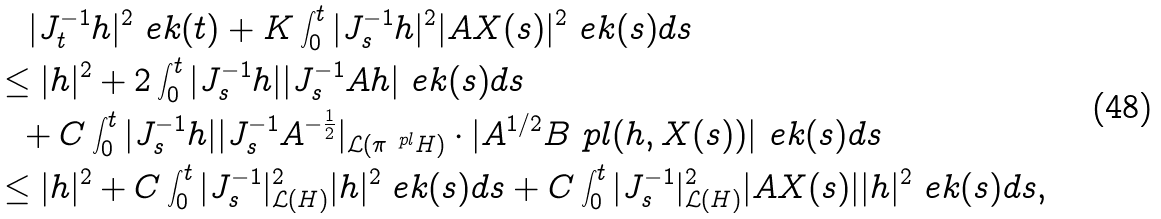Convert formula to latex. <formula><loc_0><loc_0><loc_500><loc_500>& \quad | J ^ { - 1 } _ { t } h | ^ { 2 } \ e k ( t ) + K \int _ { 0 } ^ { t } | J ^ { - 1 } _ { s } h | ^ { 2 } | A X ( s ) | ^ { 2 } \ e k ( s ) d s \\ & \leq | h | ^ { 2 } + 2 \int _ { 0 } ^ { t } | J ^ { - 1 } _ { s } h | | J ^ { - 1 } _ { s } A h | \ e k ( s ) d s \\ & \ \ + C \int _ { 0 } ^ { t } | J ^ { - 1 } _ { s } h | | J ^ { - 1 } _ { s } A ^ { - \frac { 1 } { 2 } } | _ { \mathcal { L } ( \pi ^ { \ p l } H ) } \cdot | A ^ { 1 / 2 } B ^ { \ } p l ( h , X ( s ) ) | \ e k ( s ) d s \\ & \leq | h | ^ { 2 } + C \int _ { 0 } ^ { t } | J ^ { - 1 } _ { s } | _ { \mathcal { L } ( H ) } ^ { 2 } | h | ^ { 2 } \ e k ( s ) d s + C \int _ { 0 } ^ { t } | J ^ { - 1 } _ { s } | _ { \mathcal { L } ( H ) } ^ { 2 } | A X ( s ) | | h | ^ { 2 } \ e k ( s ) d s ,</formula> 